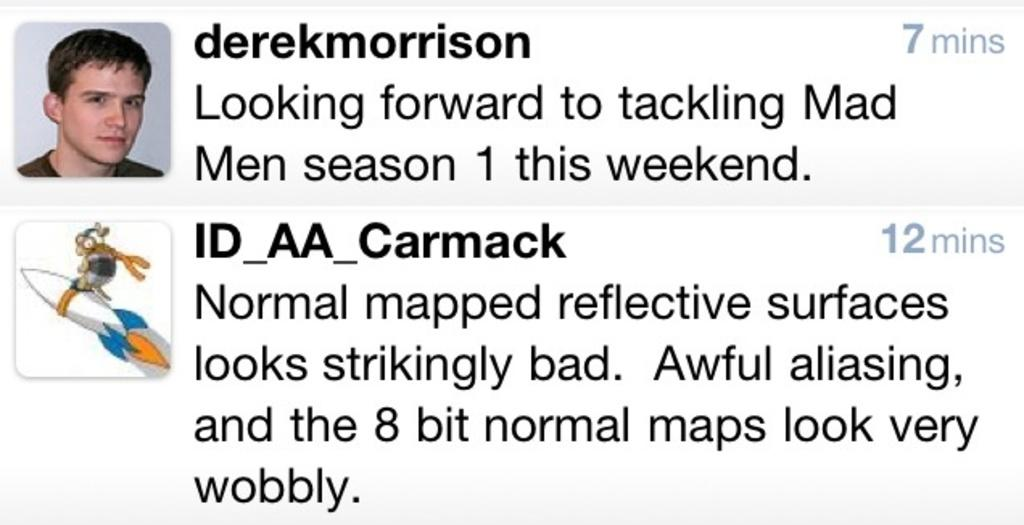What type of image is shown in the screenshot? The image is a screenshot of a web page. What can be found on the web page besides text? There are images on the web page. What information is provided on the web page? There is text on the web page. What type of branch can be seen in the image? There is no branch present in the image; it is a screenshot of a web page. What shape is the wilderness in the image? There is no wilderness present in the image; it is a screenshot of a web page. 